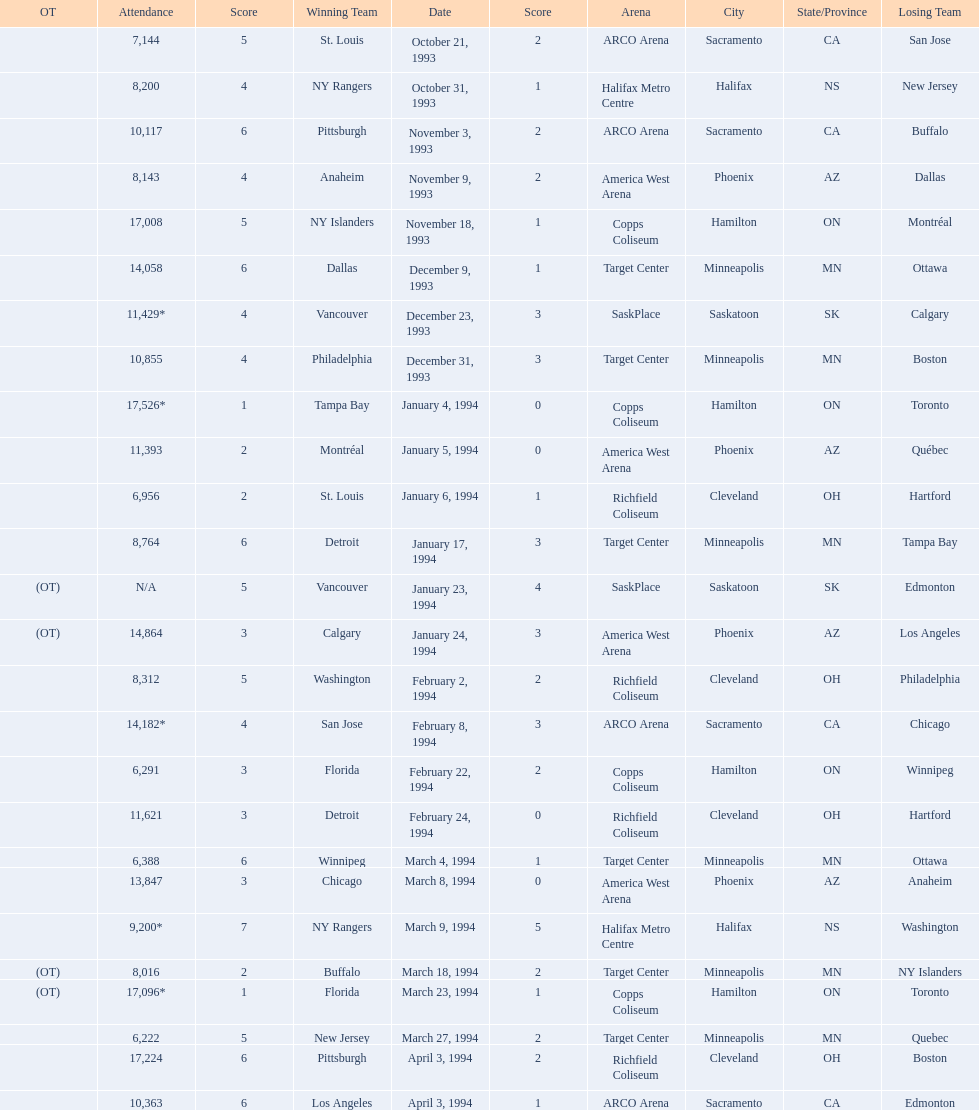On which dates were all the games? October 21, 1993, October 31, 1993, November 3, 1993, November 9, 1993, November 18, 1993, December 9, 1993, December 23, 1993, December 31, 1993, January 4, 1994, January 5, 1994, January 6, 1994, January 17, 1994, January 23, 1994, January 24, 1994, February 2, 1994, February 8, 1994, February 22, 1994, February 24, 1994, March 4, 1994, March 8, 1994, March 9, 1994, March 18, 1994, March 23, 1994, March 27, 1994, April 3, 1994, April 3, 1994. What were the attendances? 7,144, 8,200, 10,117, 8,143, 17,008, 14,058, 11,429*, 10,855, 17,526*, 11,393, 6,956, 8,764, N/A, 14,864, 8,312, 14,182*, 6,291, 11,621, 6,388, 13,847, 9,200*, 8,016, 17,096*, 6,222, 17,224, 10,363. And between december 23, 1993 and january 24, 1994, which game had the highest turnout? January 4, 1994. 